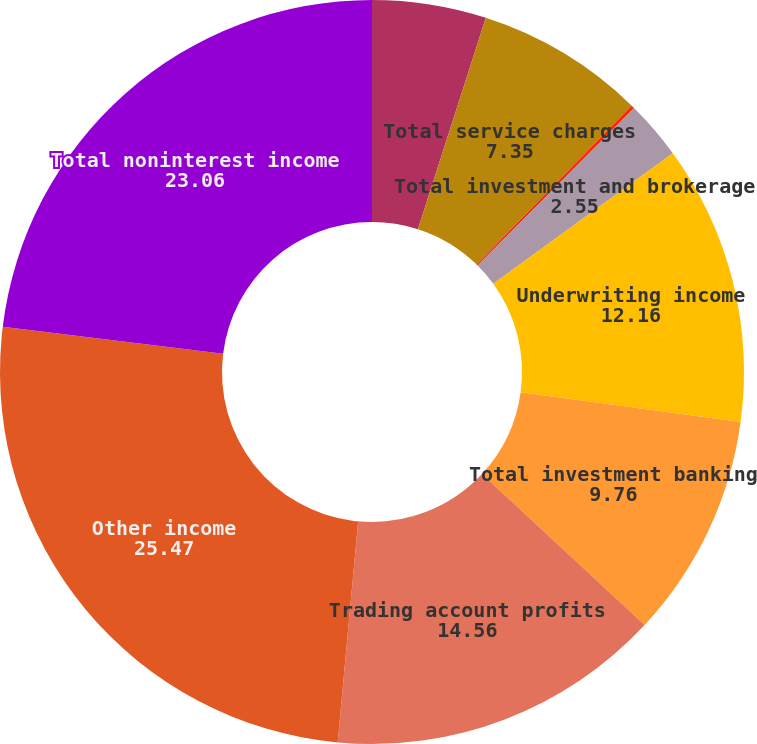<chart> <loc_0><loc_0><loc_500><loc_500><pie_chart><fcel>Deposit-related fees<fcel>Total service charges<fcel>Brokerage fees<fcel>Total investment and brokerage<fcel>Underwriting income<fcel>Total investment banking<fcel>Trading account profits<fcel>Other income<fcel>Total noninterest income<nl><fcel>4.95%<fcel>7.35%<fcel>0.14%<fcel>2.55%<fcel>12.16%<fcel>9.76%<fcel>14.56%<fcel>25.47%<fcel>23.06%<nl></chart> 